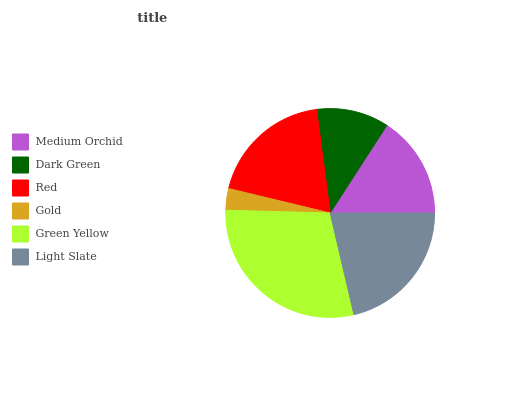Is Gold the minimum?
Answer yes or no. Yes. Is Green Yellow the maximum?
Answer yes or no. Yes. Is Dark Green the minimum?
Answer yes or no. No. Is Dark Green the maximum?
Answer yes or no. No. Is Medium Orchid greater than Dark Green?
Answer yes or no. Yes. Is Dark Green less than Medium Orchid?
Answer yes or no. Yes. Is Dark Green greater than Medium Orchid?
Answer yes or no. No. Is Medium Orchid less than Dark Green?
Answer yes or no. No. Is Red the high median?
Answer yes or no. Yes. Is Medium Orchid the low median?
Answer yes or no. Yes. Is Light Slate the high median?
Answer yes or no. No. Is Green Yellow the low median?
Answer yes or no. No. 